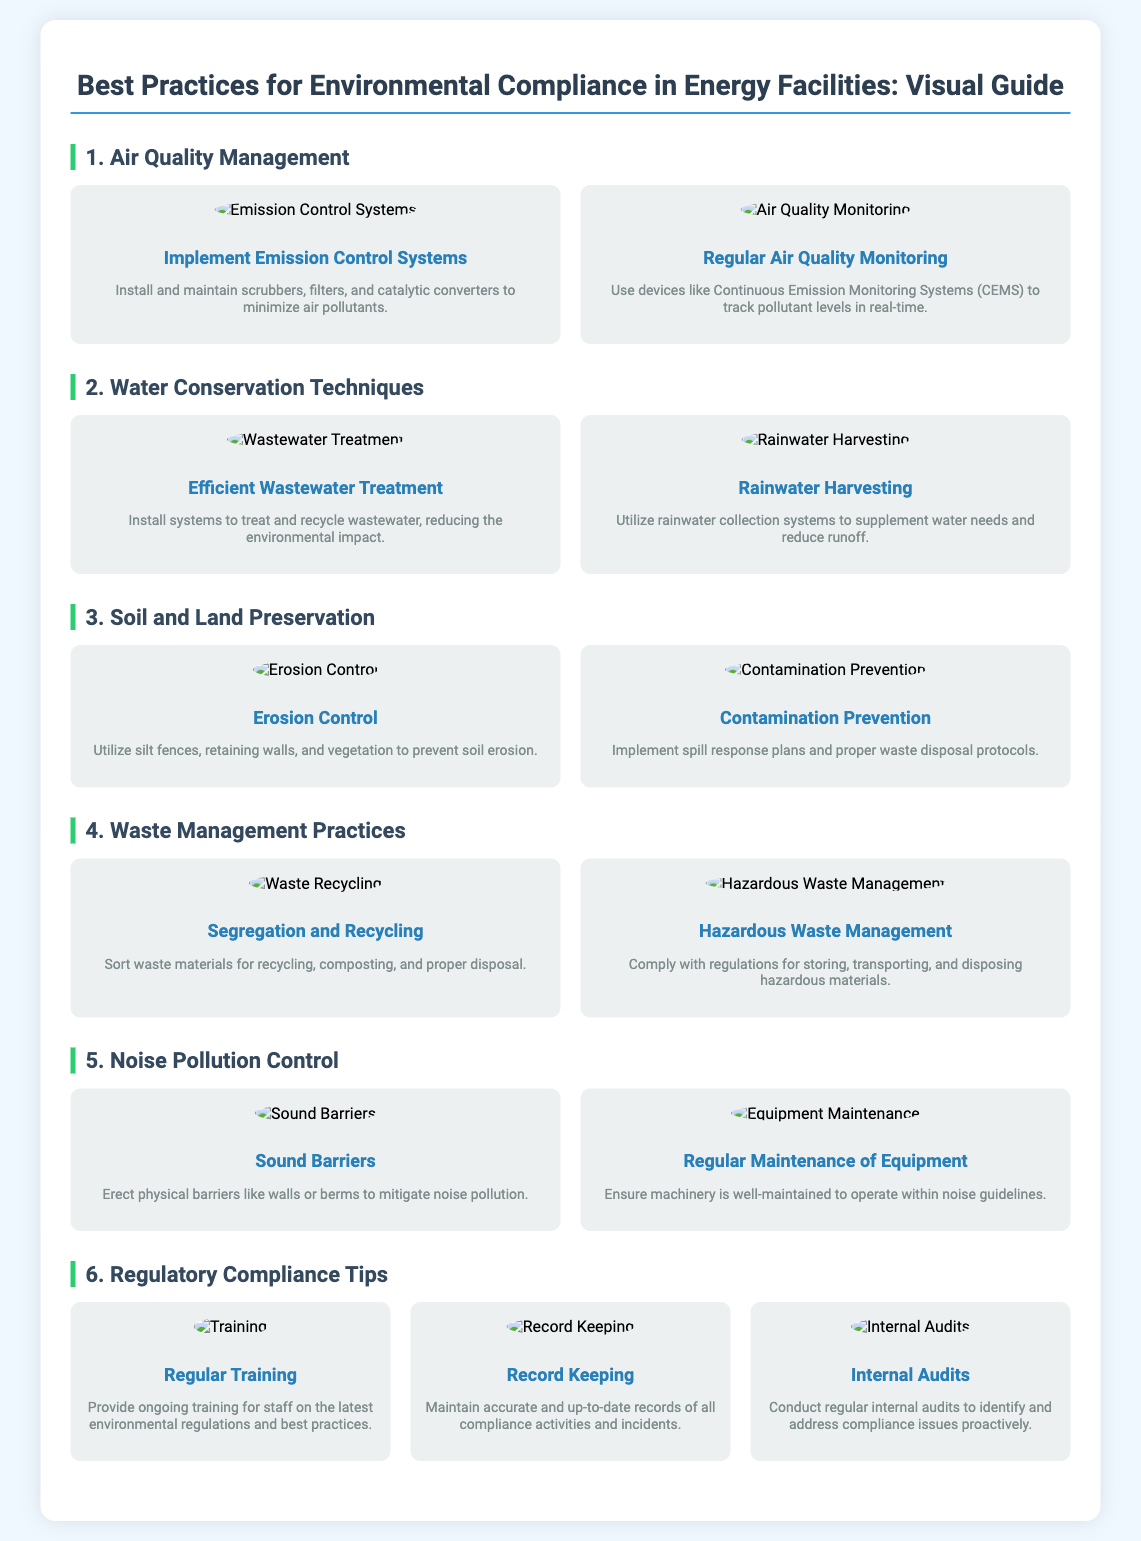What are the two key areas of air quality management mentioned? In the air quality management section, two key practices are highlighted: implementing emission control systems and regular air quality monitoring.
Answer: Emission Control Systems, Regular Air Quality Monitoring What is one method for wastewater treatment mentioned? The document refers to efficient wastewater treatment as a method, emphasizing the importance of systems to treat and recycle wastewater.
Answer: Efficient Wastewater Treatment What is a practice to prevent soil erosion described in the poster? The section on soil and land preservation includes erosion control, which involves using silt fences, retaining walls, and vegetation.
Answer: Erosion Control Which practice relates to noise pollution control? The noise pollution control section mentions erecting sound barriers and conducting regular maintenance of equipment as practices to mitigate noise.
Answer: Sound Barriers What should be maintained according to the regulatory compliance tips? The document emphasizes the importance of record keeping to maintain accurate and up-to-date records of compliance activities and incidents.
Answer: Record Keeping How many items are listed under the regulatory compliance tips? The regulatory compliance section includes three distinct items related to maintaining compliance: regular training, record keeping, and internal audits.
Answer: 3 What is one environmental practice associated with rainwater? The poster highlights rainwater harvesting as a technique for conserving water and reducing runoff in energy facilities.
Answer: Rainwater Harvesting Which equipment-related practice is emphasized for noise control? The poster suggests that regular maintenance of equipment is crucial for complying with noise guidelines, making it a significant practice in noise pollution control.
Answer: Regular Maintenance of Equipment 